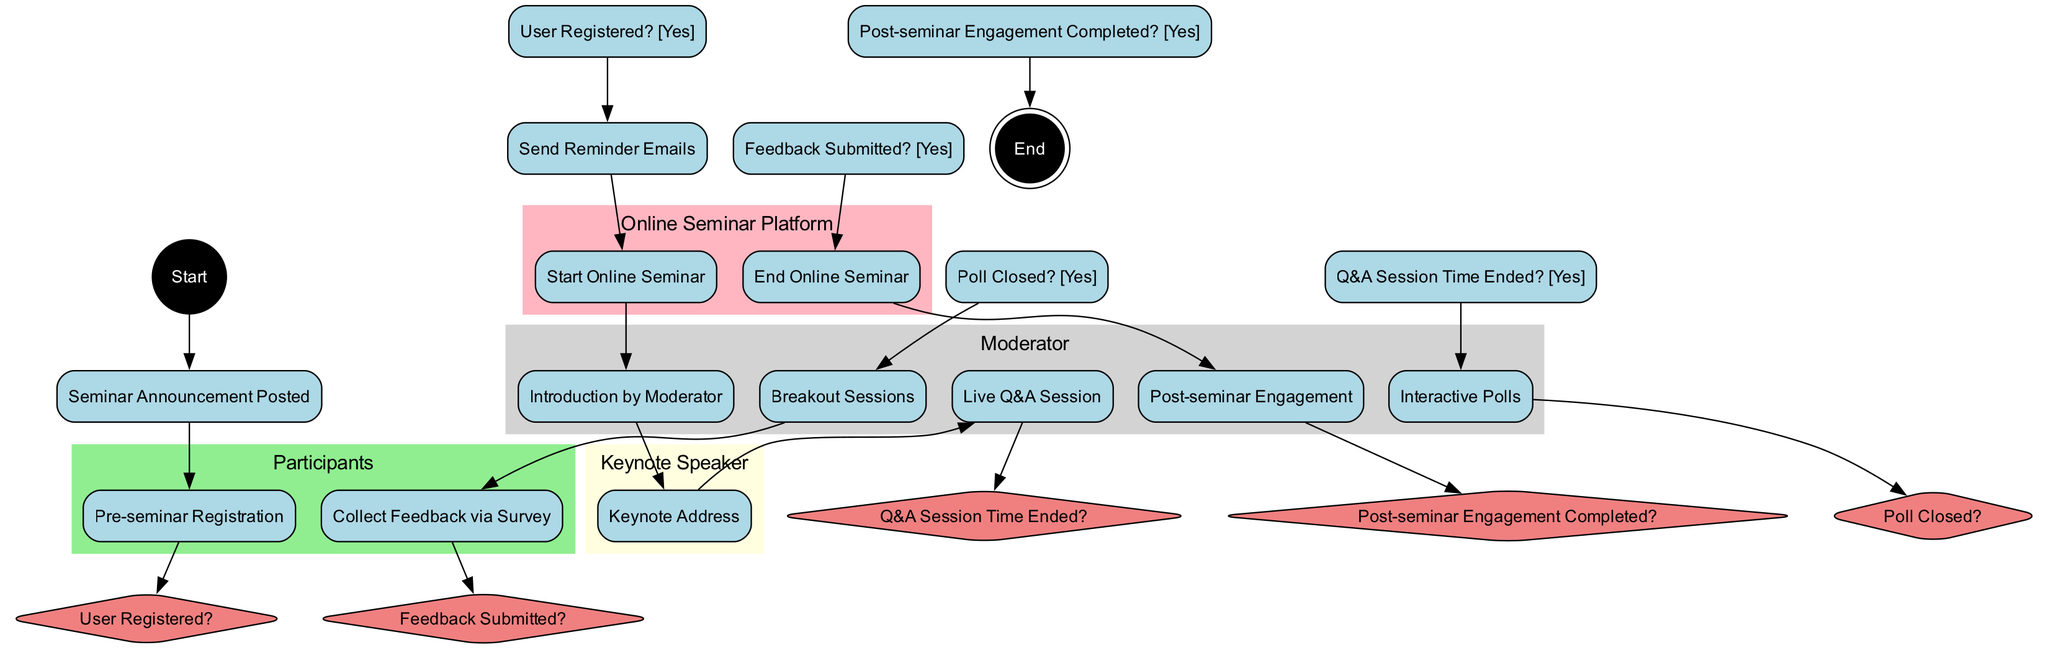What is the first activity in the diagram? The diagram starts with the entry point labeled as "Start" which connects to the first activity "Seminar Announcement Posted". Therefore, the first activity is clearly indicated in the flow.
Answer: Seminar Announcement Posted How many decision nodes are present in the diagram? The diagram lists five decision nodes: "User Registered?", "Q&A Session Time Ended?", "Poll Closed?", "Feedback Submitted?", and "Post-seminar Engagement Completed?". Counting these gives a total of five decision nodes.
Answer: 5 Which actor is responsible for the "Keynote Address"? The diagram clearly indicates that the "Keynote Speaker" is the actor responsible for the activity labeled "Keynote Address". This is established through the swimlane that contains this activity.
Answer: Keynote Speaker What activity occurs after "Live Q&A Session"? The flow of the diagram shows that after the "Live Q&A Session", the next activity is determined based on whether the "Q&A Session Time Ended?" decision is answered affirmatively, leading to "Interactive Polls".
Answer: Interactive Polls What happens if "User Registered?" is answered 'No'? In the diagram, if "User Registered?" is answered 'No', the flow does not proceed to "Send Reminder Emails" or any subsequent activities, placing a halt to this part of the engagement process.
Answer: No action proceeds What is the endpoint of the engagement process? The diagram indicates that the endpoint is reached when the activity "Post-seminar Engagement" is completed, leading to the termination node labeled "End". This clearly marks the conclusion of the engagement process.
Answer: End 